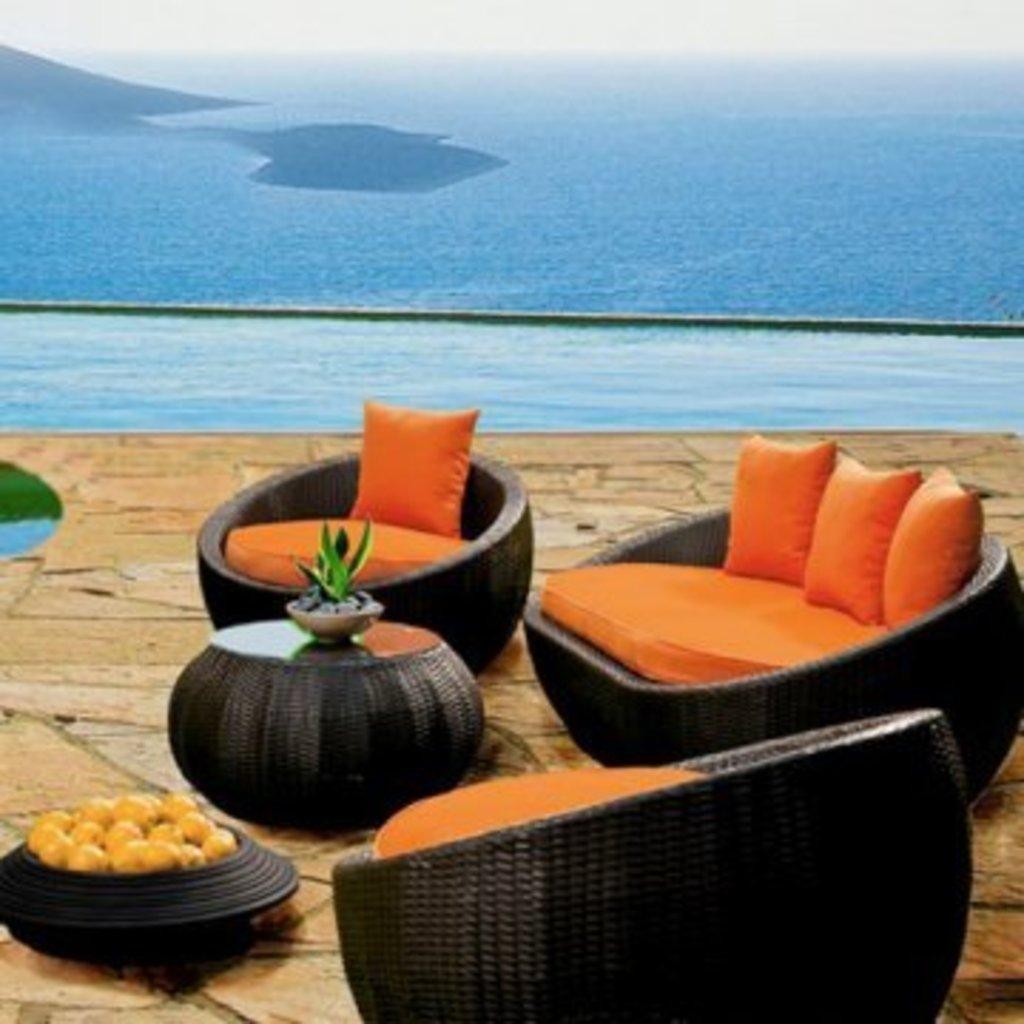Could you give a brief overview of what you see in this image? In this image I can see few black colour chairs, a black colour table, few orange colour cushions and here I can see number of yellow colour things. In the background I can see water and here I can see a plant. 